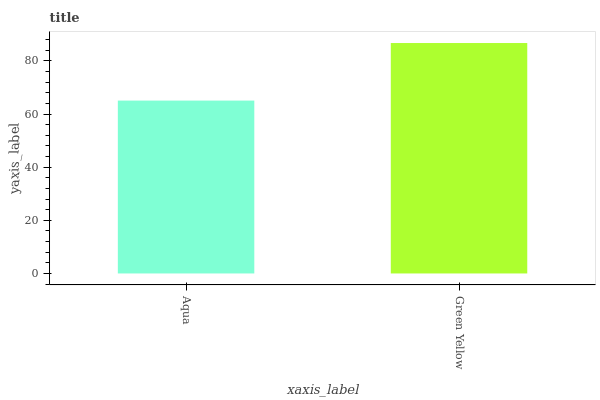Is Aqua the minimum?
Answer yes or no. Yes. Is Green Yellow the maximum?
Answer yes or no. Yes. Is Green Yellow the minimum?
Answer yes or no. No. Is Green Yellow greater than Aqua?
Answer yes or no. Yes. Is Aqua less than Green Yellow?
Answer yes or no. Yes. Is Aqua greater than Green Yellow?
Answer yes or no. No. Is Green Yellow less than Aqua?
Answer yes or no. No. Is Green Yellow the high median?
Answer yes or no. Yes. Is Aqua the low median?
Answer yes or no. Yes. Is Aqua the high median?
Answer yes or no. No. Is Green Yellow the low median?
Answer yes or no. No. 